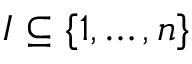Convert formula to latex. <formula><loc_0><loc_0><loc_500><loc_500>I \subseteq \{ 1 , \dots , n \}</formula> 